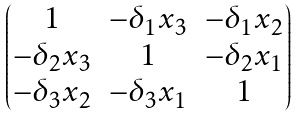<formula> <loc_0><loc_0><loc_500><loc_500>\begin{pmatrix} 1 & - \delta _ { 1 } x _ { 3 } & - \delta _ { 1 } x _ { 2 } \\ - \delta _ { 2 } x _ { 3 } & 1 & - \delta _ { 2 } x _ { 1 } \\ - \delta _ { 3 } x _ { 2 } & - \delta _ { 3 } x _ { 1 } & 1 \end{pmatrix}</formula> 